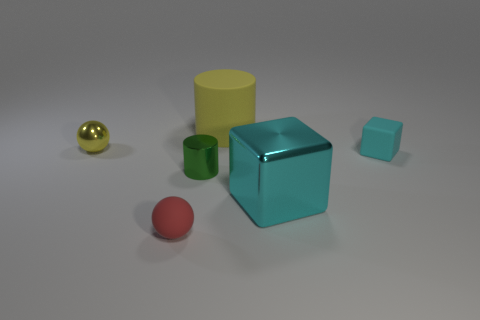There is a big object that is on the right side of the big object that is on the left side of the large cyan thing; what is its color?
Your response must be concise. Cyan. Do the small ball that is on the left side of the small red rubber thing and the rubber block have the same color?
Give a very brief answer. No. There is a big object that is to the right of the big yellow thing; what is it made of?
Keep it short and to the point. Metal. How big is the matte sphere?
Give a very brief answer. Small. Is the material of the tiny thing that is in front of the big cyan thing the same as the tiny green thing?
Offer a very short reply. No. How many small blue rubber balls are there?
Provide a short and direct response. 0. How many objects are metal cylinders or yellow metallic balls?
Ensure brevity in your answer.  2. There is a big thing in front of the cyan thing that is on the right side of the big cyan cube; what number of green metallic cylinders are in front of it?
Your answer should be very brief. 0. Is there any other thing that has the same color as the big matte object?
Offer a terse response. Yes. Do the small metallic thing that is on the left side of the tiny red object and the tiny matte object behind the red ball have the same color?
Ensure brevity in your answer.  No. 